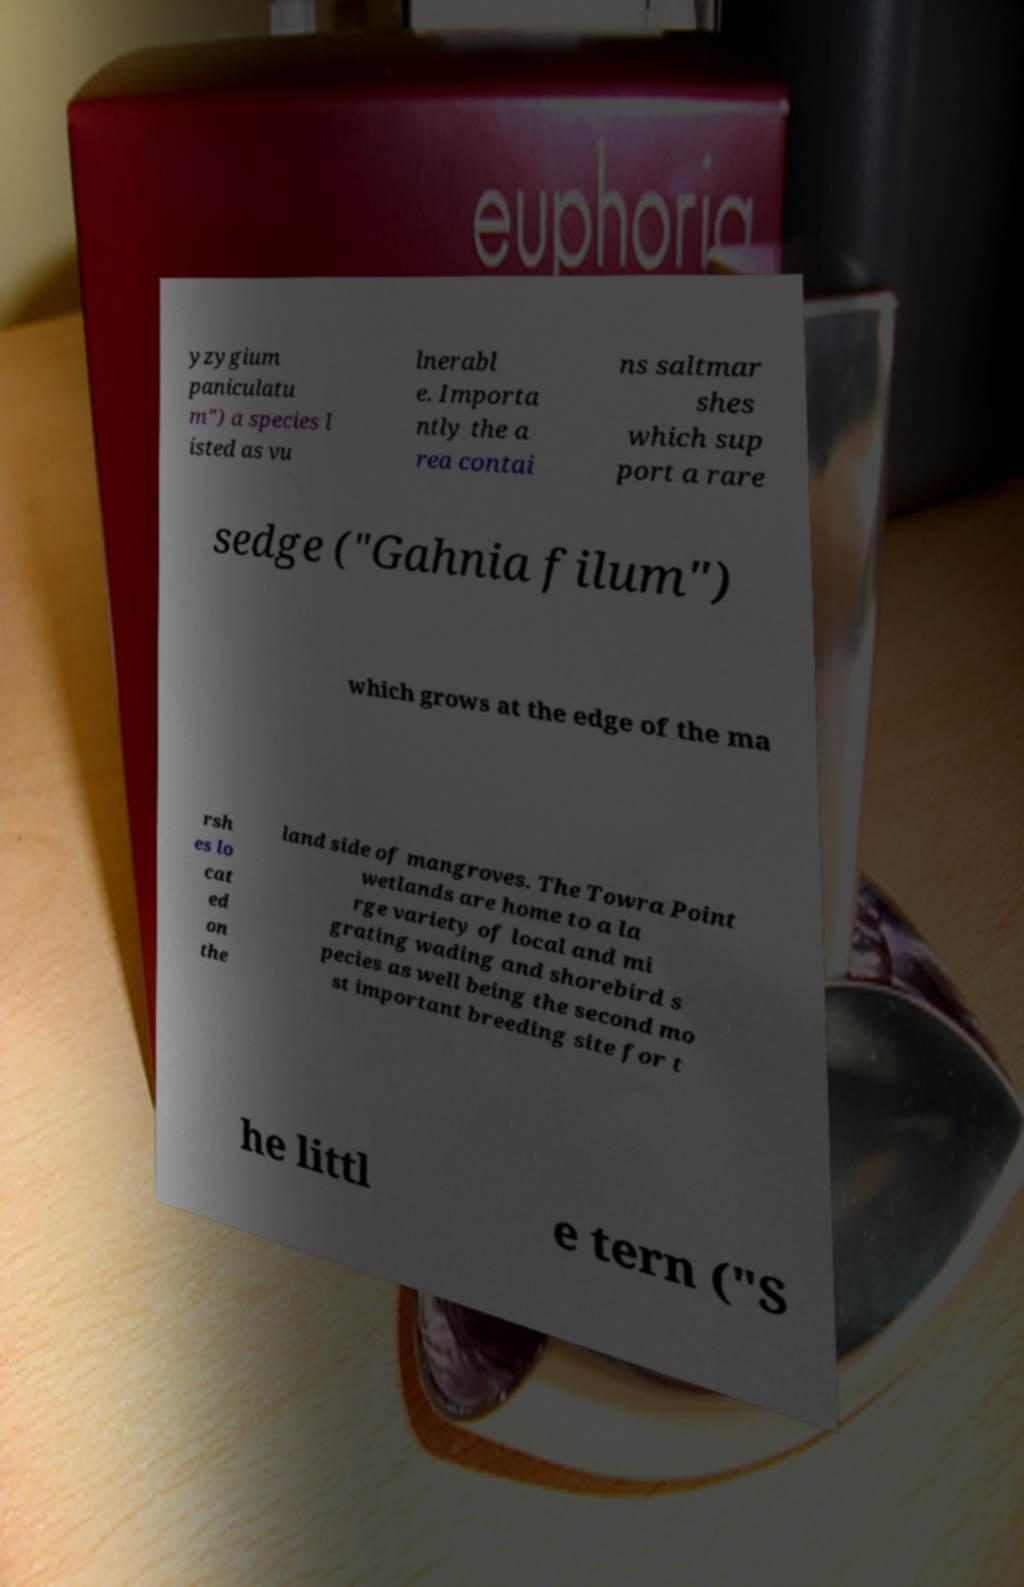What messages or text are displayed in this image? I need them in a readable, typed format. yzygium paniculatu m") a species l isted as vu lnerabl e. Importa ntly the a rea contai ns saltmar shes which sup port a rare sedge ("Gahnia filum") which grows at the edge of the ma rsh es lo cat ed on the land side of mangroves. The Towra Point wetlands are home to a la rge variety of local and mi grating wading and shorebird s pecies as well being the second mo st important breeding site for t he littl e tern ("S 